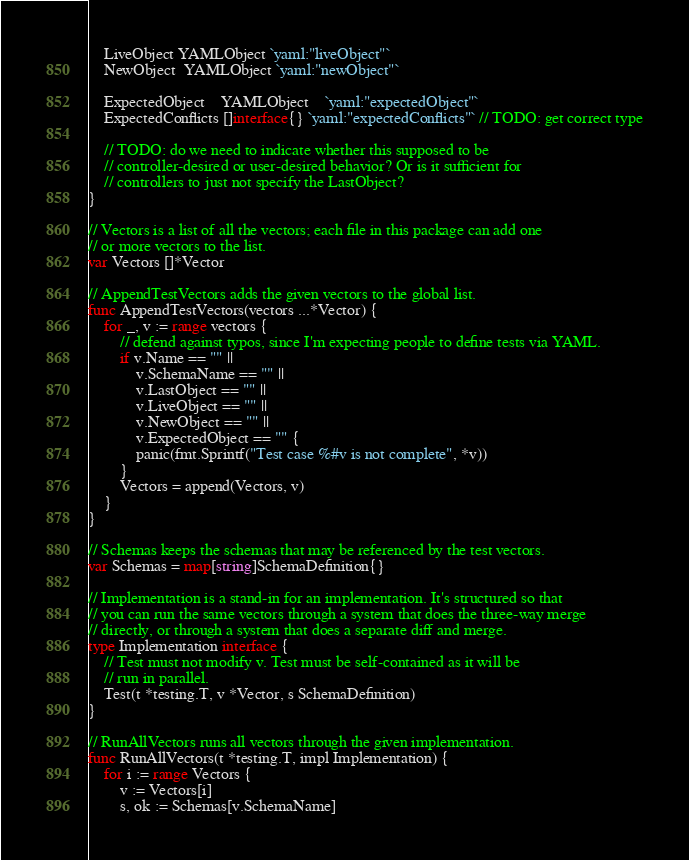Convert code to text. <code><loc_0><loc_0><loc_500><loc_500><_Go_>	LiveObject YAMLObject `yaml:"liveObject"`
	NewObject  YAMLObject `yaml:"newObject"`

	ExpectedObject    YAMLObject    `yaml:"expectedObject"`
	ExpectedConflicts []interface{} `yaml:"expectedConflicts"` // TODO: get correct type

	// TODO: do we need to indicate whether this supposed to be
	// controller-desired or user-desired behavior? Or is it sufficient for
	// controllers to just not specify the LastObject?
}

// Vectors is a list of all the vectors; each file in this package can add one
// or more vectors to the list.
var Vectors []*Vector

// AppendTestVectors adds the given vectors to the global list.
func AppendTestVectors(vectors ...*Vector) {
	for _, v := range vectors {
		// defend against typos, since I'm expecting people to define tests via YAML.
		if v.Name == "" ||
			v.SchemaName == "" ||
			v.LastObject == "" ||
			v.LiveObject == "" ||
			v.NewObject == "" ||
			v.ExpectedObject == "" {
			panic(fmt.Sprintf("Test case %#v is not complete", *v))
		}
		Vectors = append(Vectors, v)
	}
}

// Schemas keeps the schemas that may be referenced by the test vectors.
var Schemas = map[string]SchemaDefinition{}

// Implementation is a stand-in for an implementation. It's structured so that
// you can run the same vectors through a system that does the three-way merge
// directly, or through a system that does a separate diff and merge.
type Implementation interface {
	// Test must not modify v. Test must be self-contained as it will be
	// run in parallel.
	Test(t *testing.T, v *Vector, s SchemaDefinition)
}

// RunAllVectors runs all vectors through the given implementation.
func RunAllVectors(t *testing.T, impl Implementation) {
	for i := range Vectors {
		v := Vectors[i]
		s, ok := Schemas[v.SchemaName]</code> 